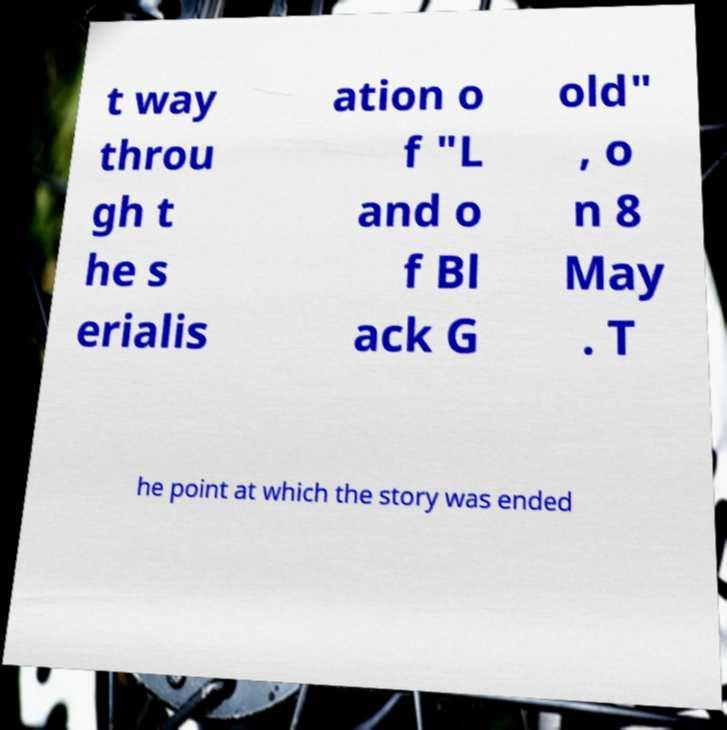Please read and relay the text visible in this image. What does it say? t way throu gh t he s erialis ation o f "L and o f Bl ack G old" , o n 8 May . T he point at which the story was ended 